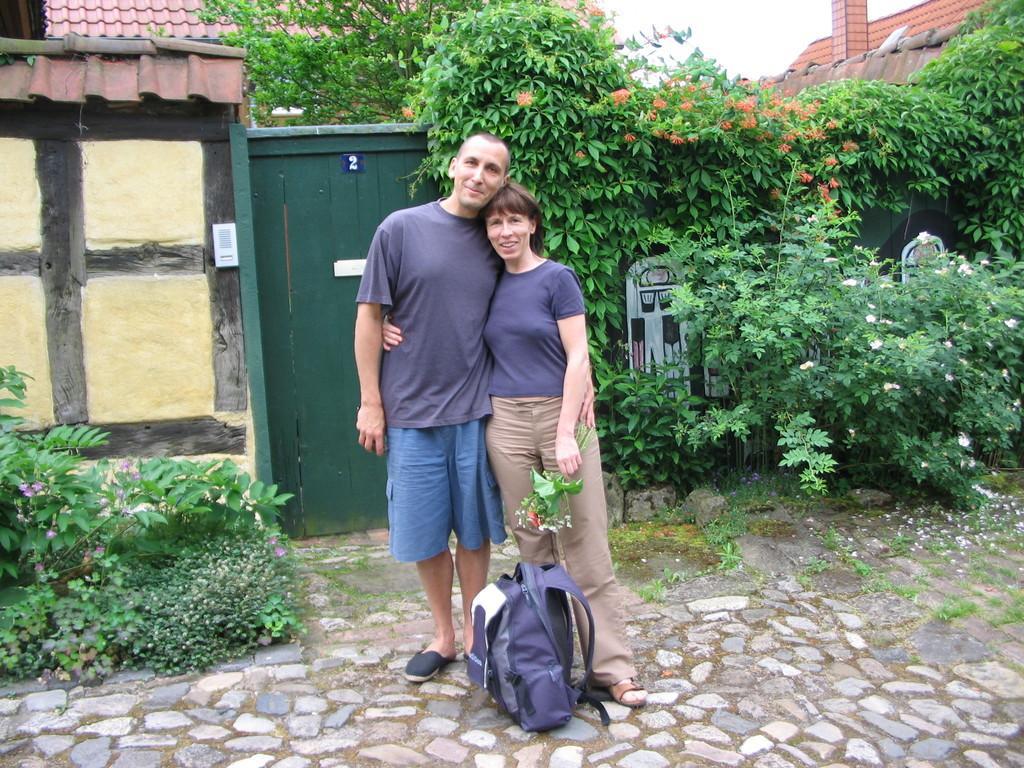Please provide a concise description of this image. In the foreground of the picture I can see a couple standing on the floor and there is a smile on their face. I can see a bag on the floor at the bottom of the picture. In the background, I can see the houses and trees. I can see the flowering plants on the left side and the right side. 